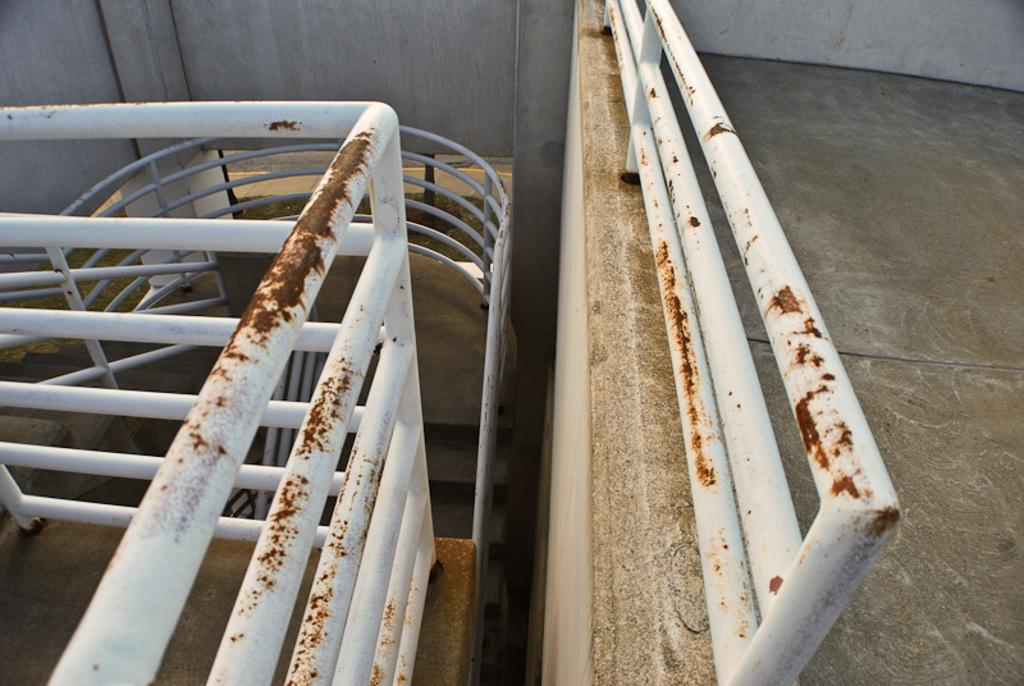What type of architectural feature can be seen in the image? There are railings and stairs in the image. What is the purpose of the railings in the image? The railings are likely for safety and support while using the stairs. What other element is present in the image? There is a wall in the image. What type of science experiment is being conducted on the wall in the image? There is no science experiment or any indication of one being conducted in the image. 